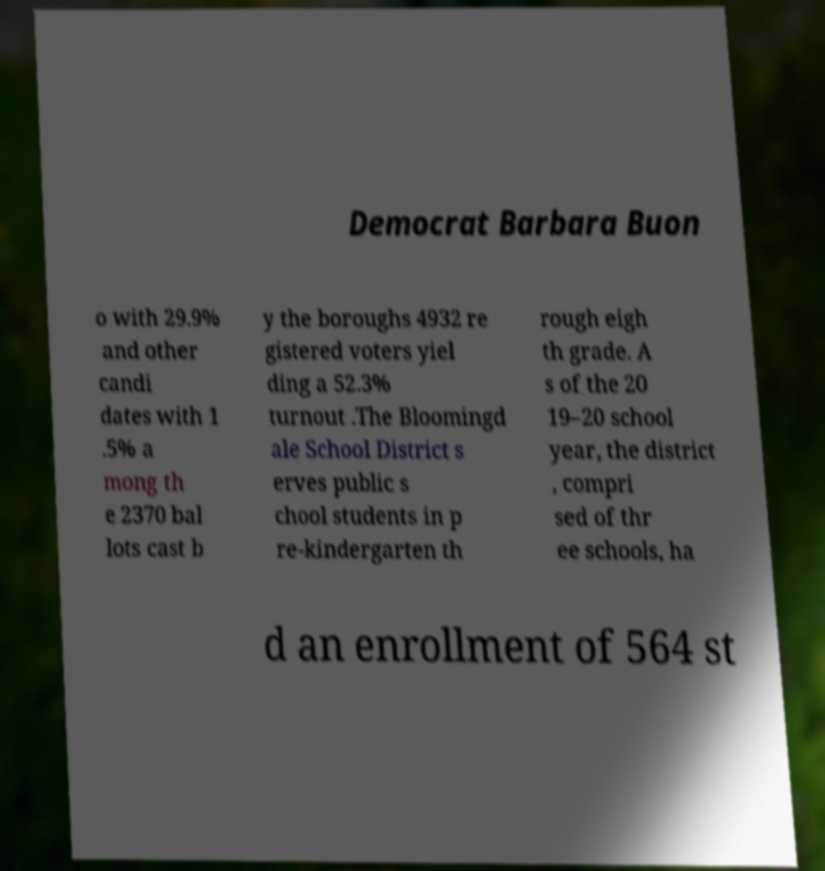Could you assist in decoding the text presented in this image and type it out clearly? Democrat Barbara Buon o with 29.9% and other candi dates with 1 .5% a mong th e 2370 bal lots cast b y the boroughs 4932 re gistered voters yiel ding a 52.3% turnout .The Bloomingd ale School District s erves public s chool students in p re-kindergarten th rough eigh th grade. A s of the 20 19–20 school year, the district , compri sed of thr ee schools, ha d an enrollment of 564 st 